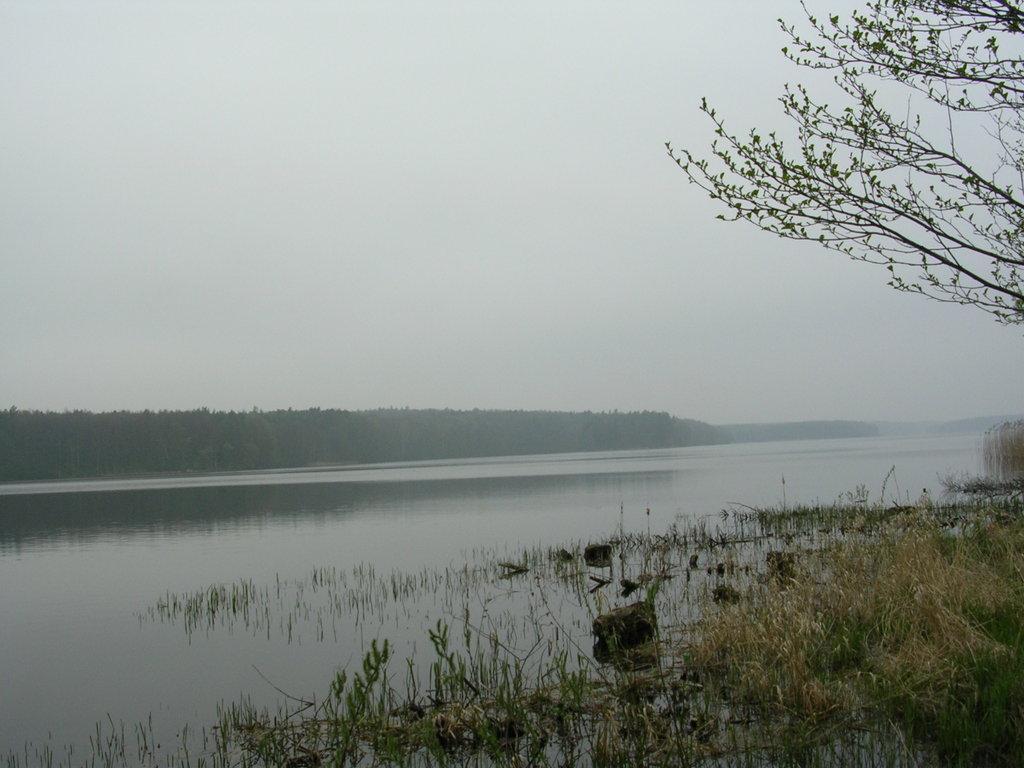Could you give a brief overview of what you see in this image? In the image there is some grass and beside the grass there is a water surface and in the background there are some trees, there is a dry tree on the right side in the front. 